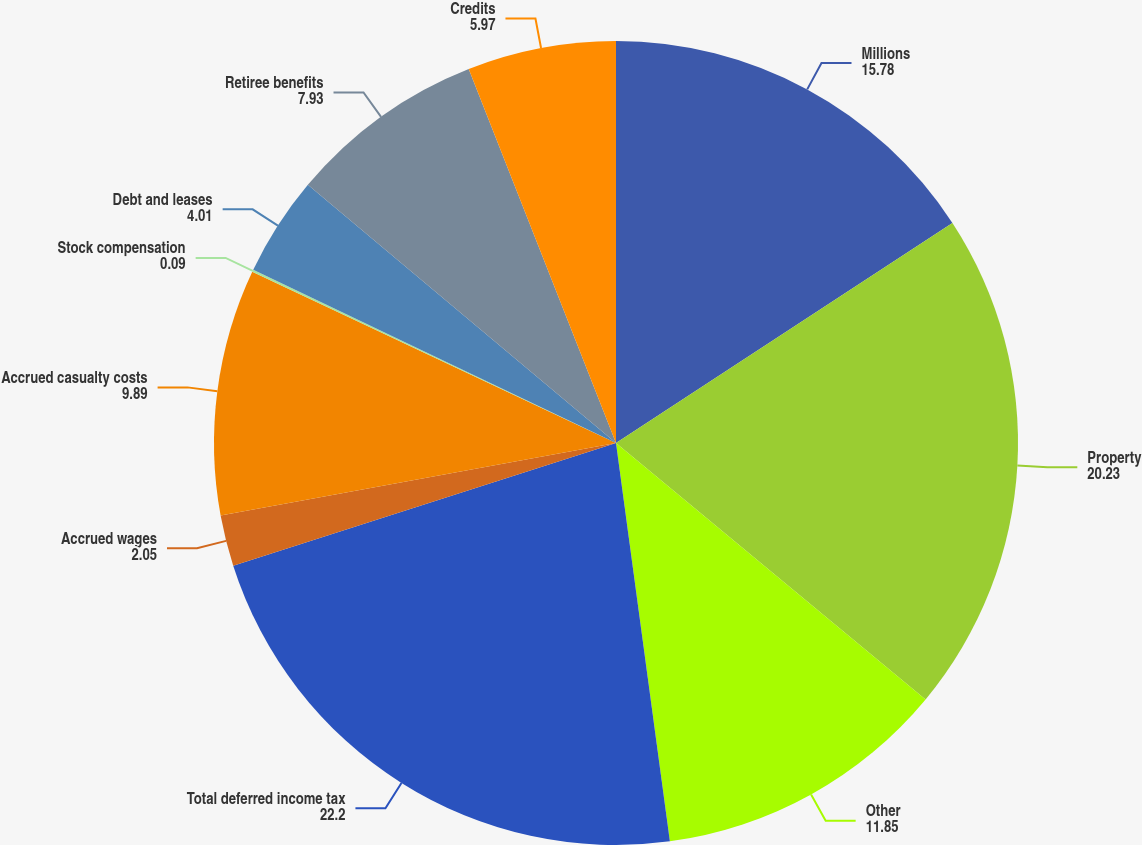Convert chart to OTSL. <chart><loc_0><loc_0><loc_500><loc_500><pie_chart><fcel>Millions<fcel>Property<fcel>Other<fcel>Total deferred income tax<fcel>Accrued wages<fcel>Accrued casualty costs<fcel>Stock compensation<fcel>Debt and leases<fcel>Retiree benefits<fcel>Credits<nl><fcel>15.78%<fcel>20.23%<fcel>11.85%<fcel>22.2%<fcel>2.05%<fcel>9.89%<fcel>0.09%<fcel>4.01%<fcel>7.93%<fcel>5.97%<nl></chart> 